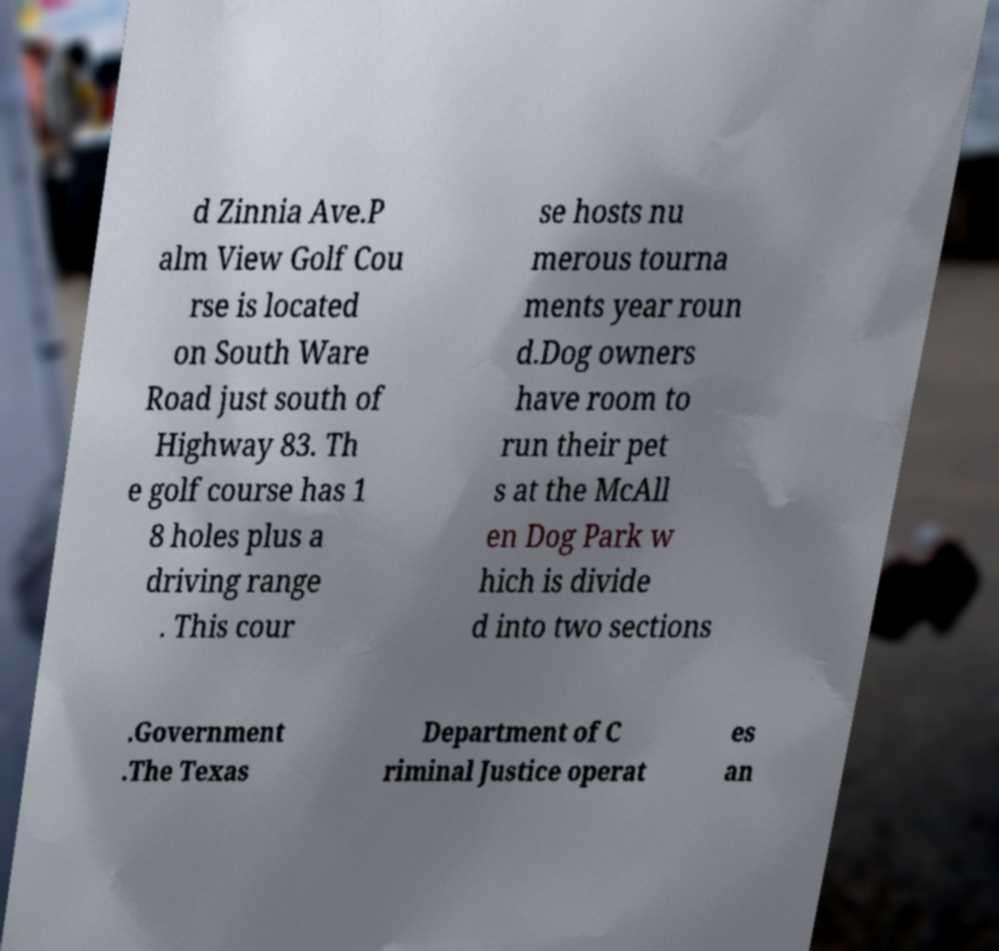I need the written content from this picture converted into text. Can you do that? d Zinnia Ave.P alm View Golf Cou rse is located on South Ware Road just south of Highway 83. Th e golf course has 1 8 holes plus a driving range . This cour se hosts nu merous tourna ments year roun d.Dog owners have room to run their pet s at the McAll en Dog Park w hich is divide d into two sections .Government .The Texas Department of C riminal Justice operat es an 